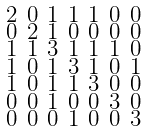Convert formula to latex. <formula><loc_0><loc_0><loc_500><loc_500>\begin{smallmatrix} 2 & 0 & 1 & 1 & 1 & 0 & 0 \\ 0 & 2 & 1 & 0 & 0 & 0 & 0 \\ 1 & 1 & 3 & 1 & 1 & 1 & 0 \\ 1 & 0 & 1 & 3 & 1 & 0 & 1 \\ 1 & 0 & 1 & 1 & 3 & 0 & 0 \\ 0 & 0 & 1 & 0 & 0 & 3 & 0 \\ 0 & 0 & 0 & 1 & 0 & 0 & 3 \end{smallmatrix}</formula> 